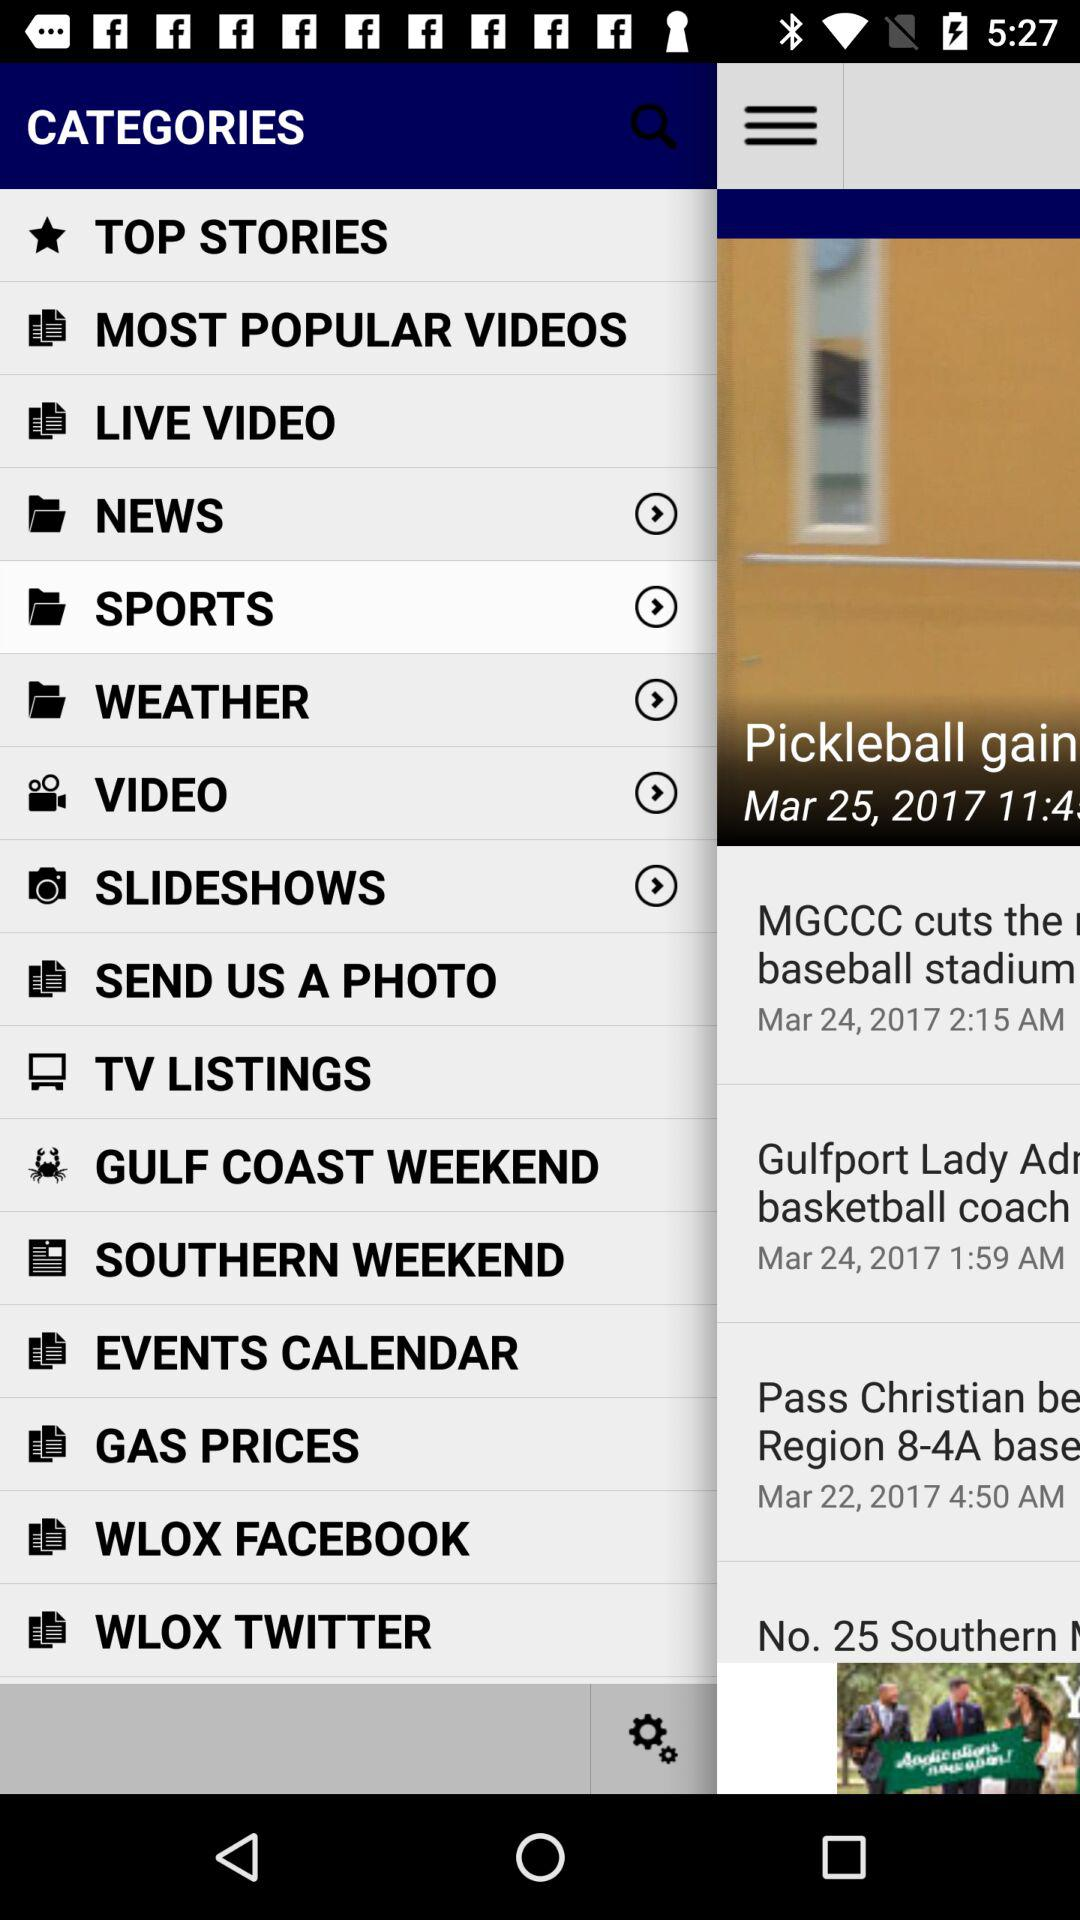Which of the item has been chosen? The item that has been chosen is "SPORTS". 